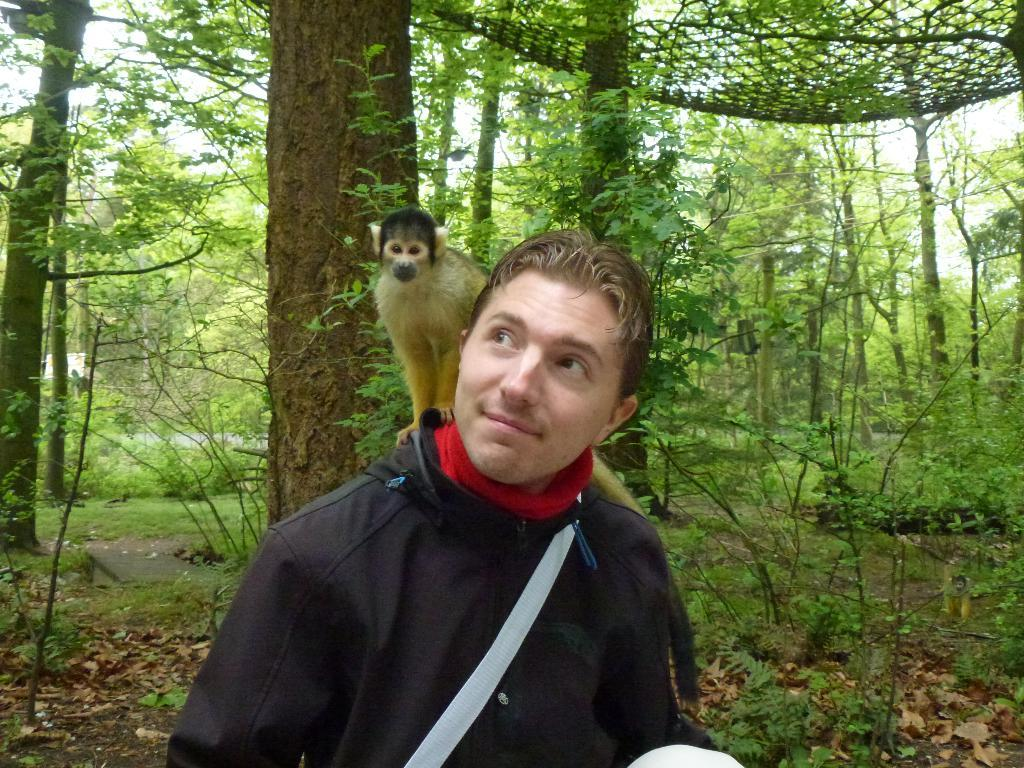Who is present in the image? There is a man in the image. What is the man wearing? The man is wearing a black jacket. What other living creature is in the image? There is a monkey in the image. What can be seen in the background of the image? There are many trees and plants in the background of the image. What color is the cloth used to cover the man's finger in the image? There is no cloth covering the man's finger in the image. 